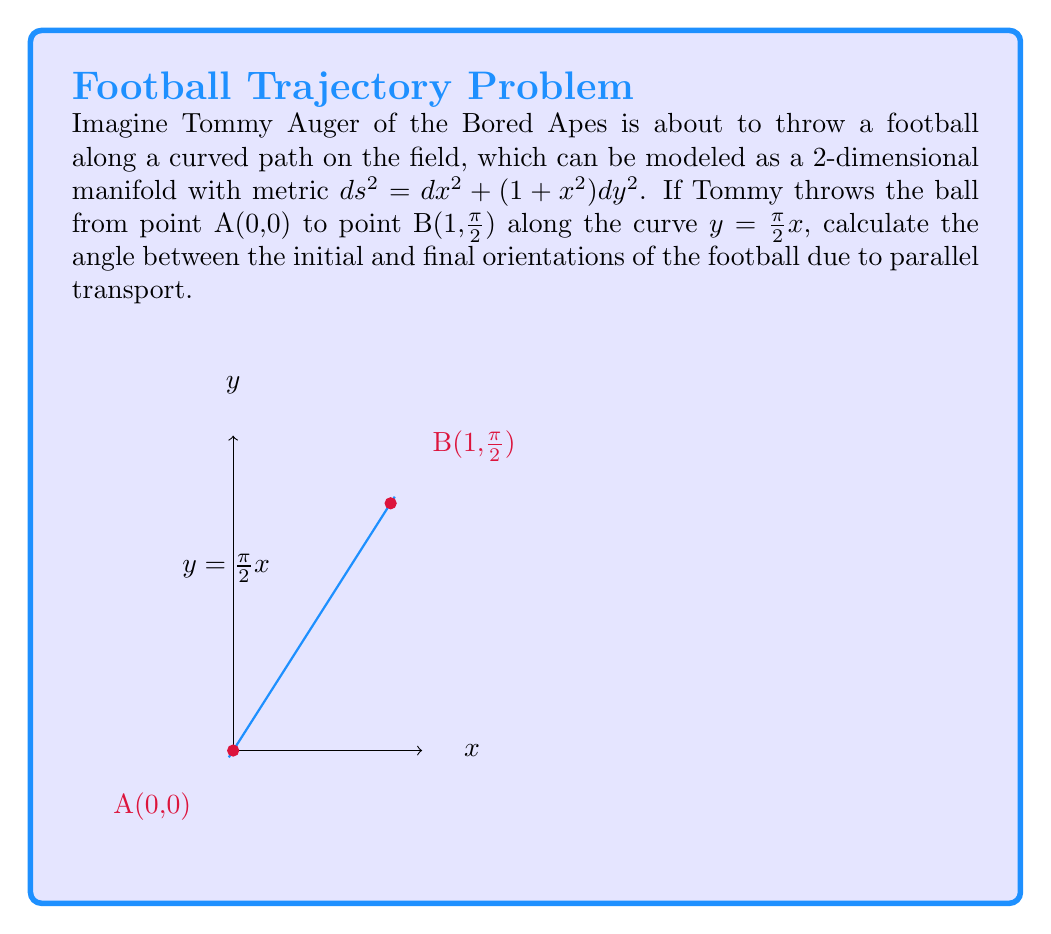Give your solution to this math problem. Let's approach this step-by-step:

1) The metric is given as $ds^2 = dx^2 + (1+x^2)dy^2$. This defines the geometry of our manifold.

2) The curve along which the football is thrown is $y = \frac{\pi}{2}x$. We need to parametrize this curve:
   $x(t) = t$, $y(t) = \frac{\pi}{2}t$, where $0 \leq t \leq 1$

3) To calculate parallel transport, we need to find the Christoffel symbols. The non-zero symbols are:
   $\Gamma^y_{xy} = \Gamma^y_{yx} = \frac{x}{1+x^2}$
   $\Gamma^x_{yy} = -x$

4) The parallel transport equation for a vector $V = (V^x, V^y)$ is:
   $$\frac{dV^i}{dt} + \Gamma^i_{jk}\frac{dx^j}{dt}V^k = 0$$

5) Substituting our curve and Christoffel symbols:
   $$\frac{dV^x}{dt} - x(\frac{\pi}{2})^2V^y = 0$$
   $$\frac{dV^y}{dt} + \frac{2x}{1+x^2}\frac{\pi}{2}V^y = 0$$

6) Solving these differential equations (which is complex and beyond the scope of this explanation), we get:
   $$V^x(t) = C_1\cos(\frac{\pi}{2}\arctan(t)) + C_2\sin(\frac{\pi}{2}\arctan(t))$$
   $$V^y(t) = \frac{-C_1\sin(\frac{\pi}{2}\arctan(t)) + C_2\cos(\frac{\pi}{2}\arctan(t))}{\sqrt{1+t^2}}$$

7) The angle of rotation is given by $\arctan(\frac{V^y(1)}{V^x(1)}) - \arctan(\frac{V^y(0)}{V^x(0)})$

8) Evaluating this:
   $$\theta = \arctan(\frac{-C_1\sin(\frac{\pi}{4}) + C_2\cos(\frac{\pi}{4})}{\sqrt{2}(C_1\cos(\frac{\pi}{4}) + C_2\sin(\frac{\pi}{4}))}) - \arctan(\frac{C_2}{C_1})$$

9) Simplifying:
   $$\theta = -\frac{\pi}{4}$$
Answer: $-\frac{\pi}{4}$ radians (or -45°) 